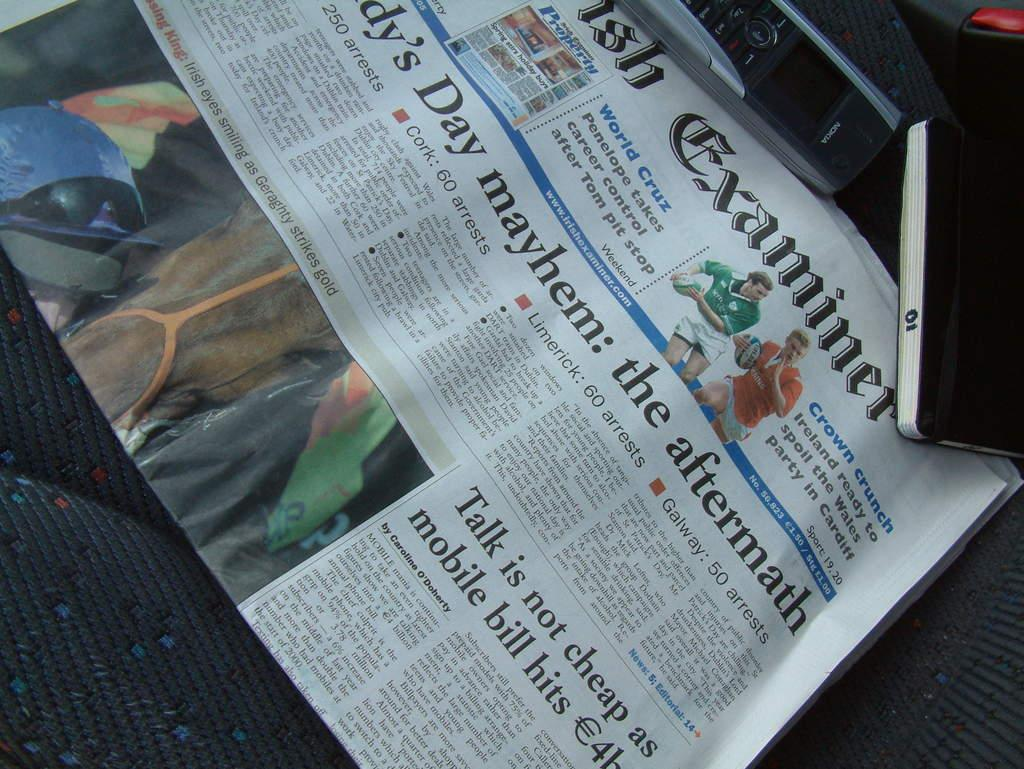Provide a one-sentence caption for the provided image. Newspaper on the aftermath and talk is not cheap as mobile bill hits. 